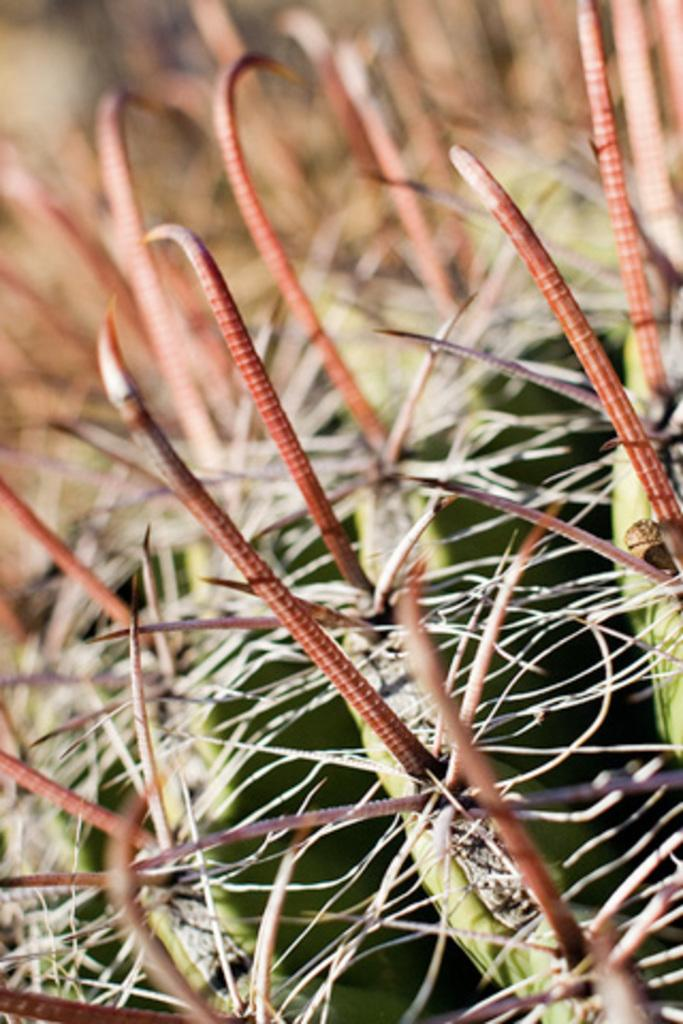What type of living organism can be seen in the image? There is a plant in the image. What type of coach can be seen in the image? There is no coach present in the image; it features a plant. What type of rose can be seen growing from the plant in the image? There is no rose present in the image; it features a plant, but the specific type of plant is not mentioned. 